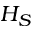Convert formula to latex. <formula><loc_0><loc_0><loc_500><loc_500>H _ { S }</formula> 